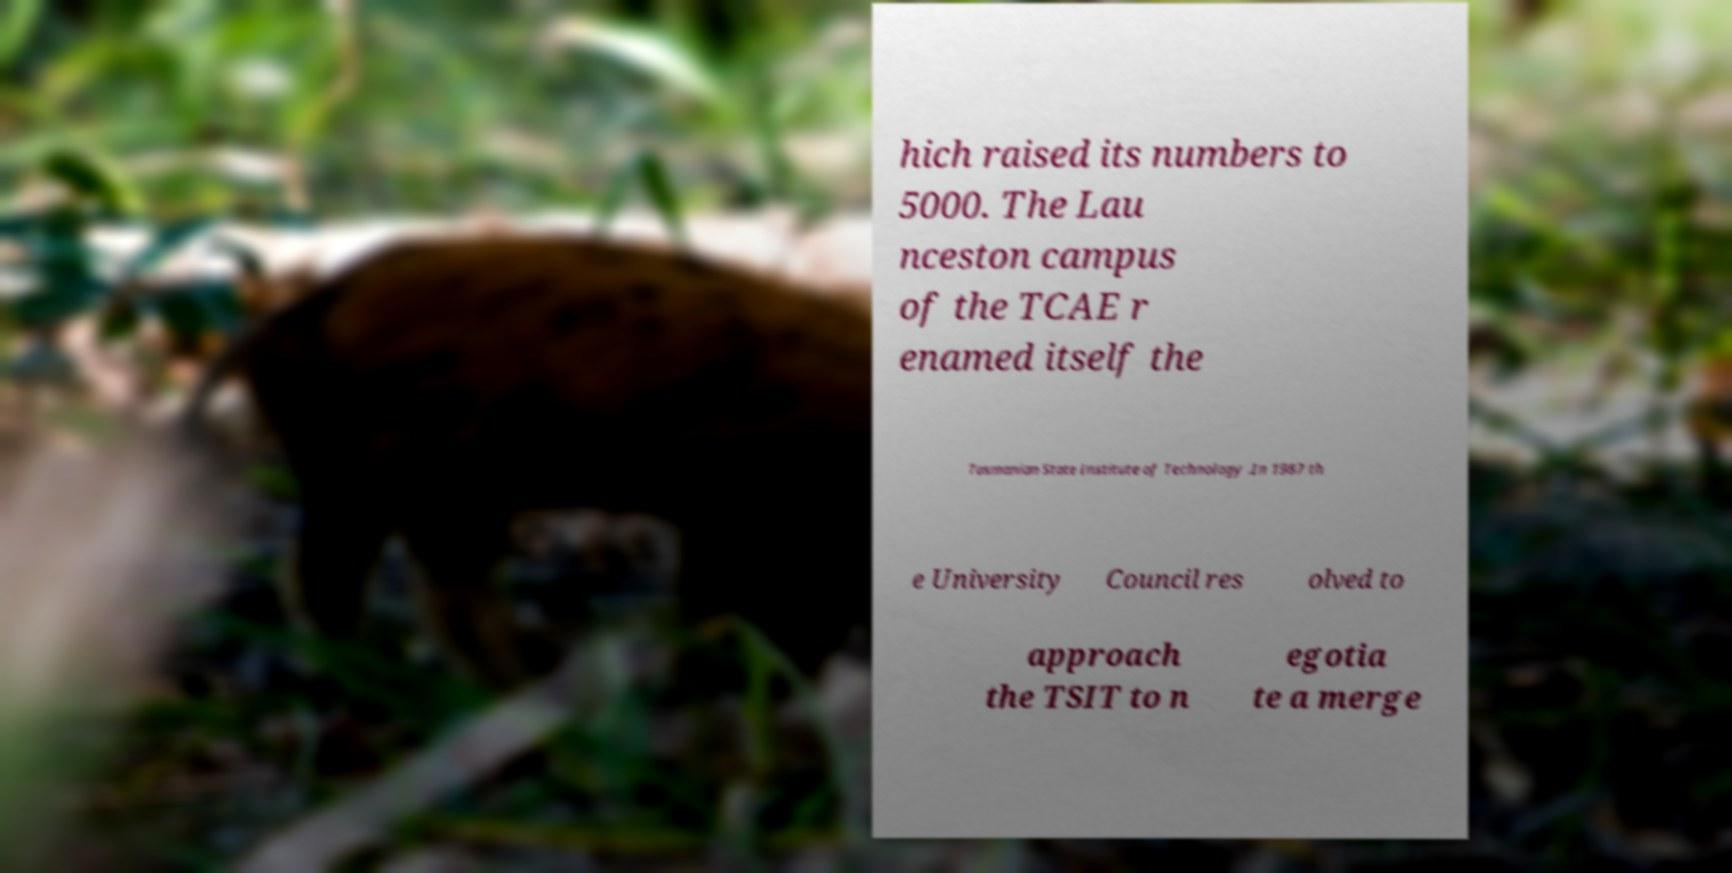For documentation purposes, I need the text within this image transcribed. Could you provide that? hich raised its numbers to 5000. The Lau nceston campus of the TCAE r enamed itself the Tasmanian State Institute of Technology .In 1987 th e University Council res olved to approach the TSIT to n egotia te a merge 